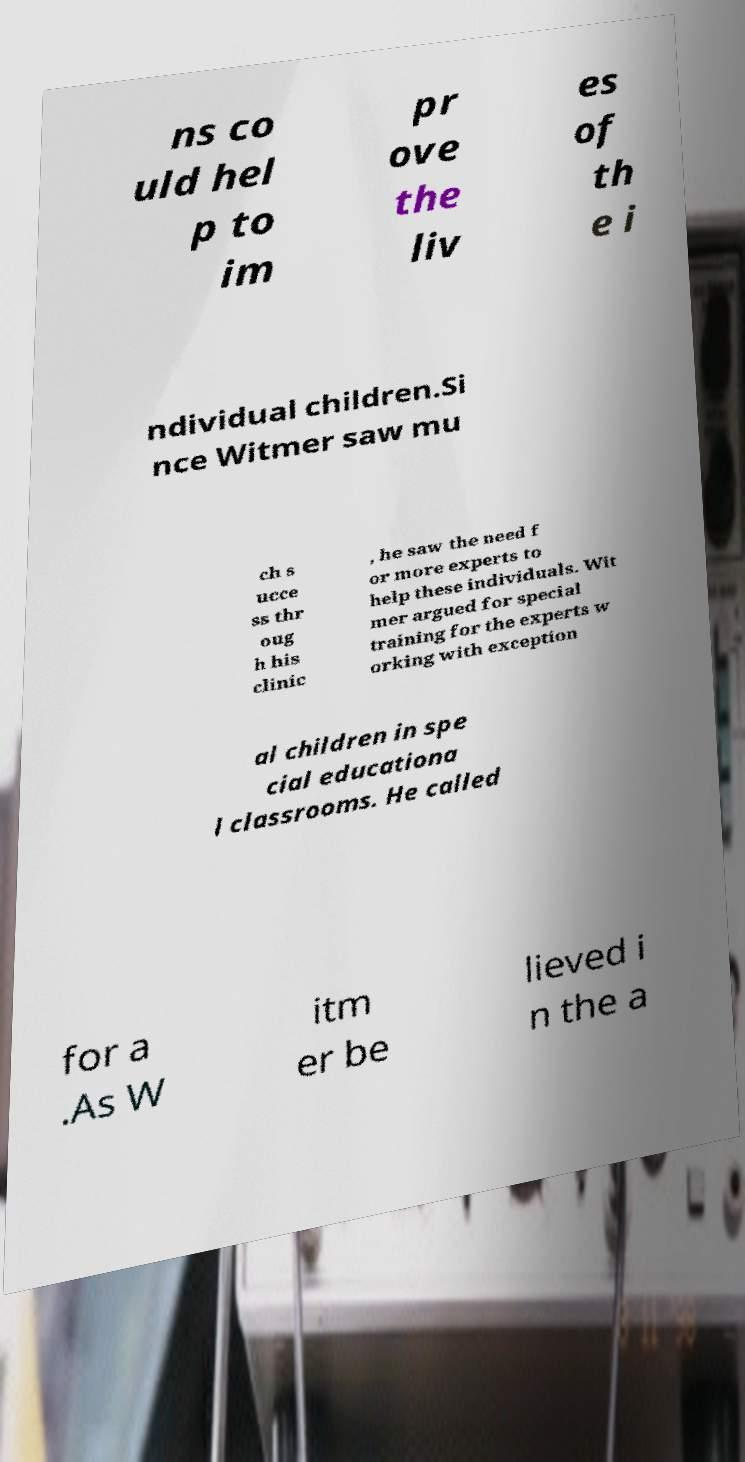Could you assist in decoding the text presented in this image and type it out clearly? ns co uld hel p to im pr ove the liv es of th e i ndividual children.Si nce Witmer saw mu ch s ucce ss thr oug h his clinic , he saw the need f or more experts to help these individuals. Wit mer argued for special training for the experts w orking with exception al children in spe cial educationa l classrooms. He called for a .As W itm er be lieved i n the a 